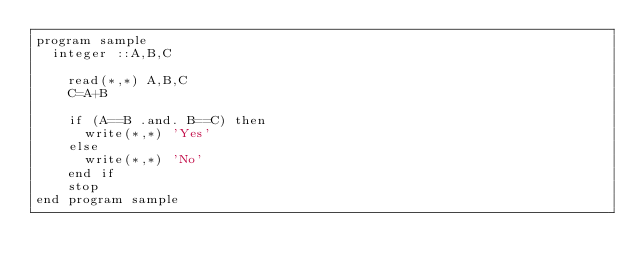<code> <loc_0><loc_0><loc_500><loc_500><_FORTRAN_>program sample
	integer ::A,B,C
    
    read(*,*) A,B,C  
    C=A+B
    
    if (A==B .and. B==C) then
    	write(*,*) 'Yes'
    else
    	write(*,*) 'No'
    end if
    stop
end program sample

</code> 